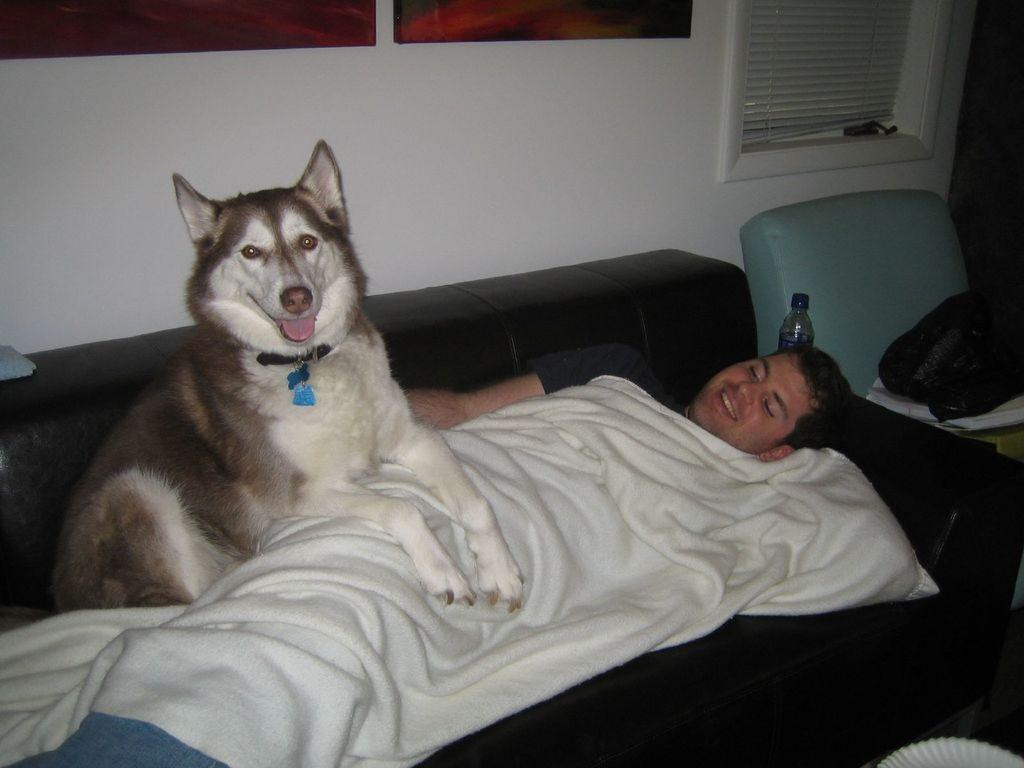What is the man in the image doing? The man is lying on the couch in the image. What is the man's facial expression? The man is smiling. Is there an animal present in the image? Yes, there is a dog on the man. What can be seen in the background of the image? There is a wall, a bottle, and a chair in the background of the image. What time does the minister start the meeting in the image? There is no minister or meeting present in the image. 